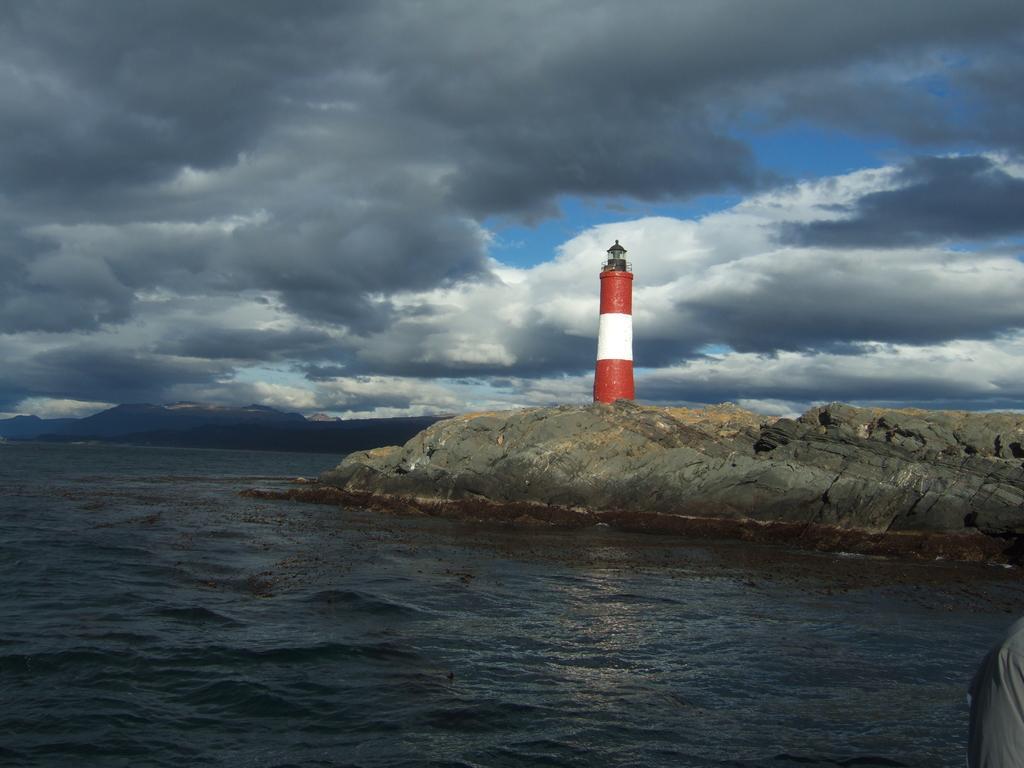Can you describe this image briefly? In this Image we can see seashore, there is a lighthouse on the rocks, and we can able to see clouded sky. 